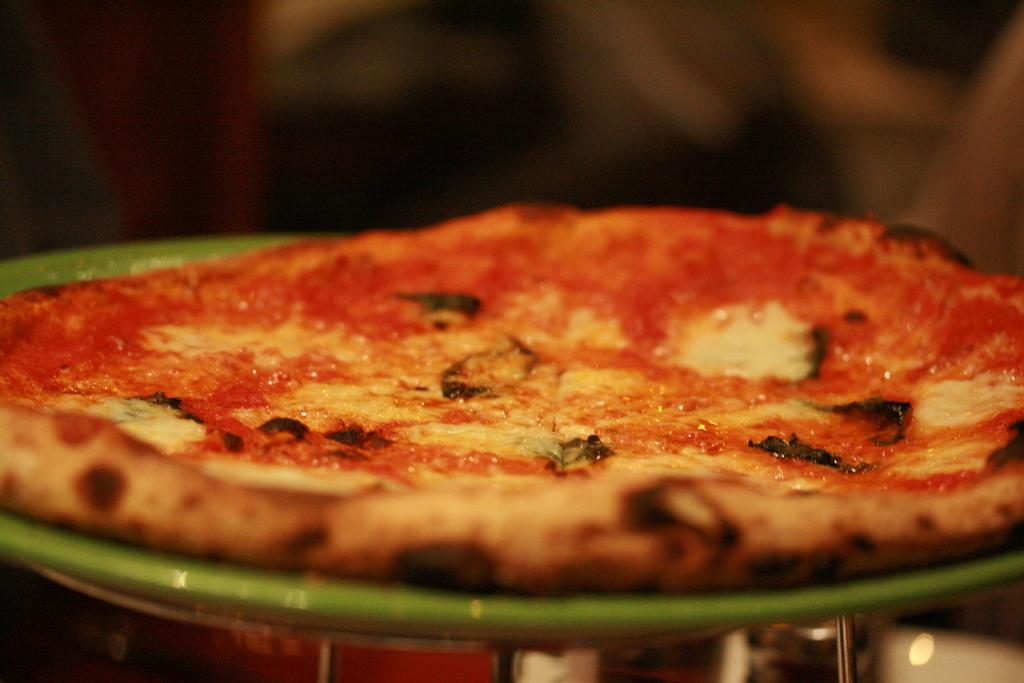What type of food is shown in the image? There is a pizza in the image. How is the pizza presented? The pizza is on a plate. Can you describe the background of the image? The background of the image is blurry. How many geese are visible in the image? There are no geese present in the image. What type of houses can be seen in the background of the image? There is no background or houses visible in the image, as the background is blurry. 